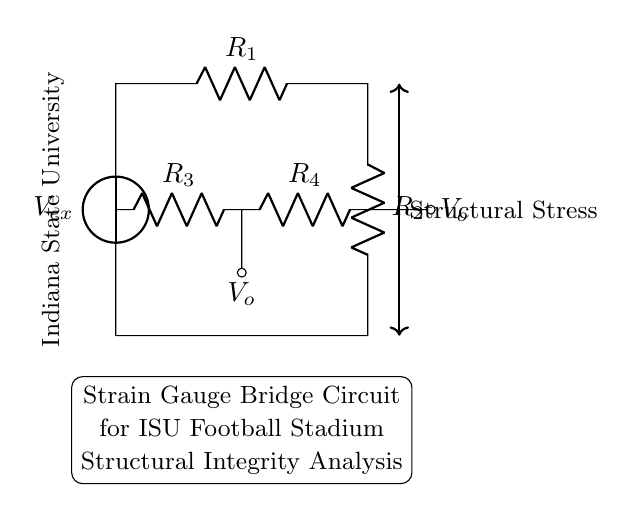What is the input voltage of the circuit? The input voltage is labeled as V_ex in the circuit diagram, indicating the voltage source connected at the input side.
Answer: V_ex What are the resistances in the circuit? The circuit contains four resistors labeled as R_1, R_2, R_3, and R_4, which are arranged in a bridge configuration.
Answer: R_1, R_2, R_3, R_4 What is the purpose of the strain gauge bridge? The strain gauge bridge is used for analyzing structural integrity, specifically related to the stresses experienced by the football stadium structure.
Answer: Structural integrity analysis How many output voltage points are indicated in the circuit? There are two output voltage points indicated in the circuit, labeled V_o at both ends of the bridge circuit.
Answer: Two What component type is primarily used for measuring deformation in the circuit? The primary component for measuring deformation in this strain gauge bridge circuit is the strain gauge itself, typically represented by the resistors in the bridge configuration.
Answer: Strain gauge What effect does structural stress have on the circuit? Structural stress affects the resistance values in the bridge, leading to changes in the output voltage (V_o) which can be measured to evaluate stress conditions.
Answer: Changes in output voltage 